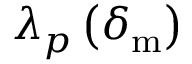Convert formula to latex. <formula><loc_0><loc_0><loc_500><loc_500>\lambda _ { p } \left ( \delta _ { m } \right )</formula> 